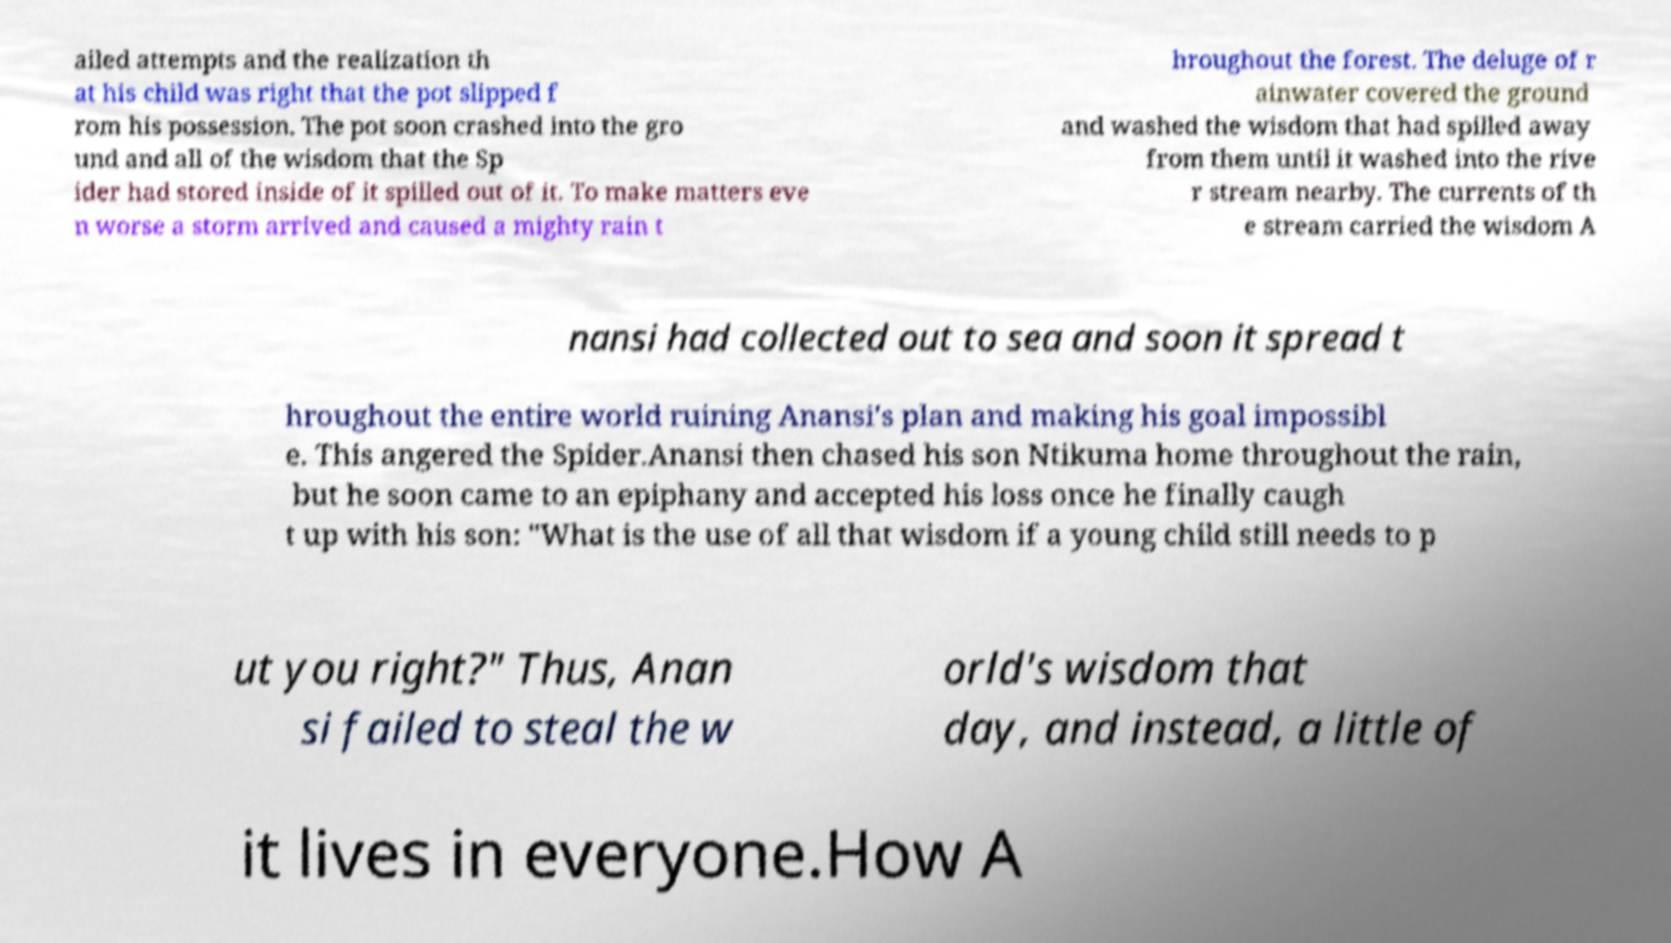Could you extract and type out the text from this image? ailed attempts and the realization th at his child was right that the pot slipped f rom his possession. The pot soon crashed into the gro und and all of the wisdom that the Sp ider had stored inside of it spilled out of it. To make matters eve n worse a storm arrived and caused a mighty rain t hroughout the forest. The deluge of r ainwater covered the ground and washed the wisdom that had spilled away from them until it washed into the rive r stream nearby. The currents of th e stream carried the wisdom A nansi had collected out to sea and soon it spread t hroughout the entire world ruining Anansi's plan and making his goal impossibl e. This angered the Spider.Anansi then chased his son Ntikuma home throughout the rain, but he soon came to an epiphany and accepted his loss once he finally caugh t up with his son: "What is the use of all that wisdom if a young child still needs to p ut you right?" Thus, Anan si failed to steal the w orld's wisdom that day, and instead, a little of it lives in everyone.How A 